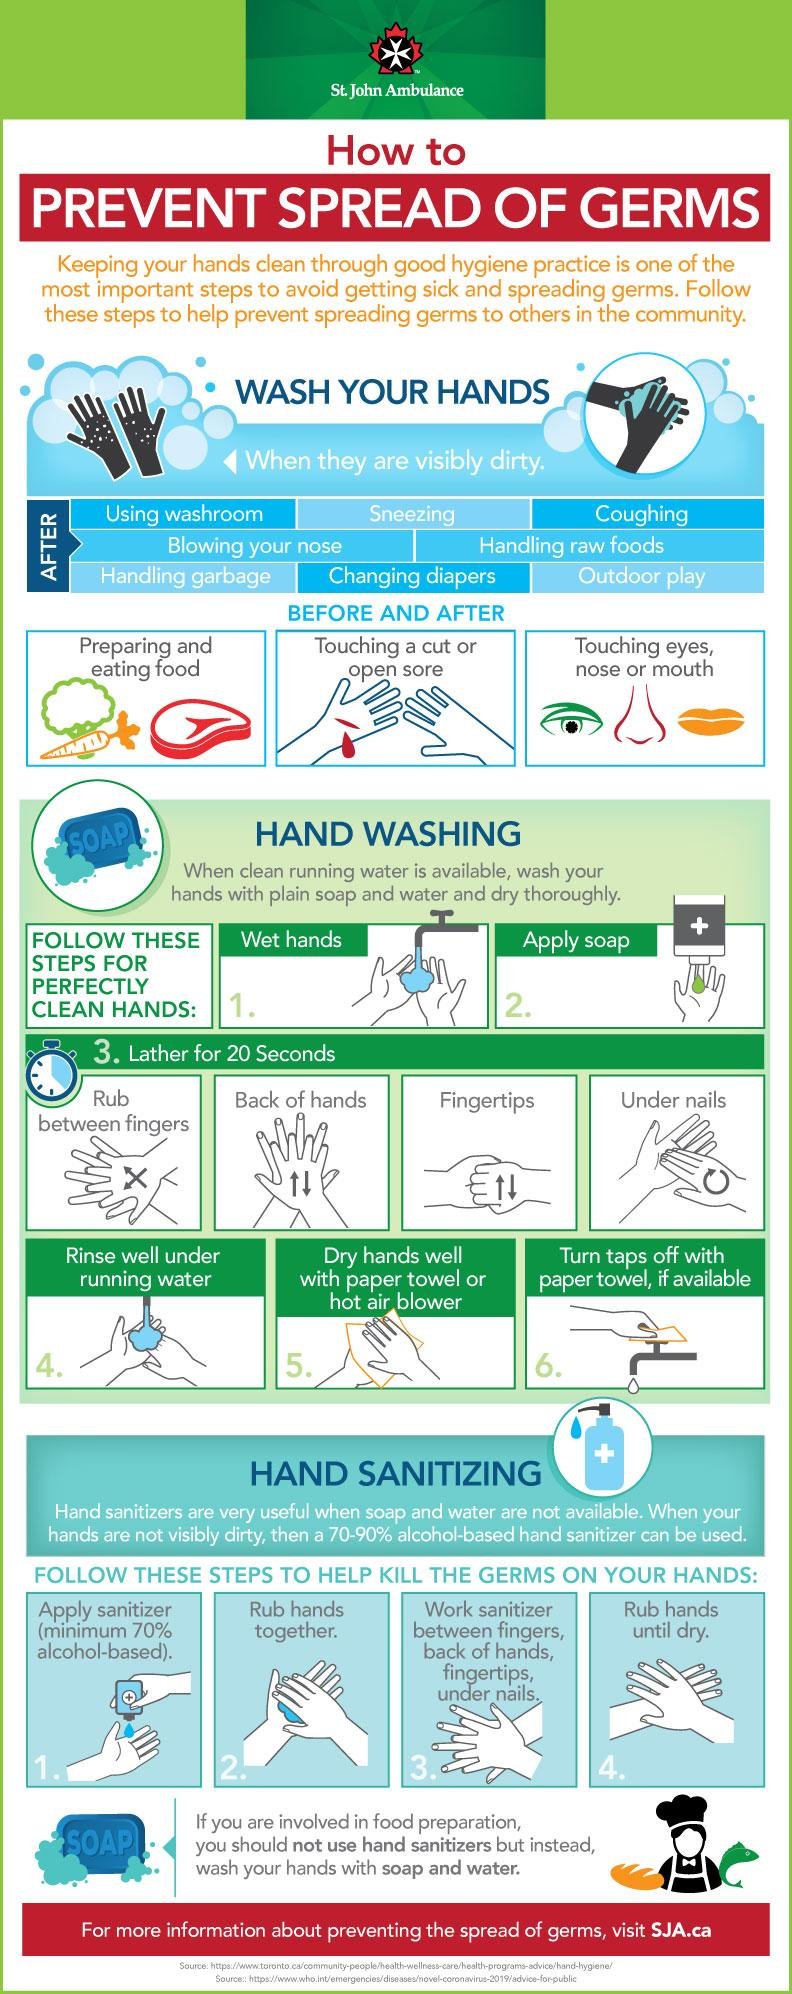Outline some significant characteristics in this image. The infographic features the facial parts of the eyes, nose, and mouth. In this infographic, there are three parts of the face that can be identified. It is necessary to take two steps to prevent the spread of germs. The "How many types of handwashing in the step "Lather for 20 seconds? 4.." refers to the different types of handwashing techniques recommended by the Centers for Disease Control and Prevention (CDC) for effective hand hygiene. The recommended technique is to lather for 20 seconds with soap and water, which is considered the most effective method for removing dirt and germs from the hands. The step of lathering for 20 seconds is crucial to ensure that the hands are properly cleaned and protected against the spread of germs and illnesses. 